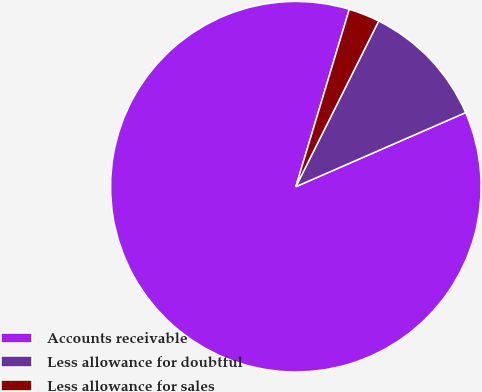Convert chart. <chart><loc_0><loc_0><loc_500><loc_500><pie_chart><fcel>Accounts receivable<fcel>Less allowance for doubtful<fcel>Less allowance for sales<nl><fcel>86.21%<fcel>11.07%<fcel>2.72%<nl></chart> 